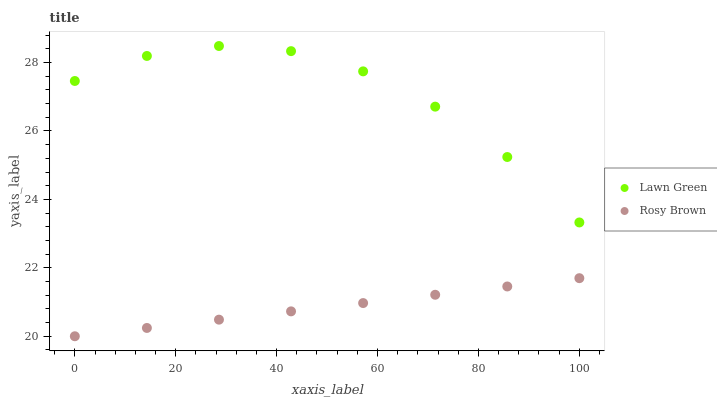Does Rosy Brown have the minimum area under the curve?
Answer yes or no. Yes. Does Lawn Green have the maximum area under the curve?
Answer yes or no. Yes. Does Rosy Brown have the maximum area under the curve?
Answer yes or no. No. Is Rosy Brown the smoothest?
Answer yes or no. Yes. Is Lawn Green the roughest?
Answer yes or no. Yes. Is Rosy Brown the roughest?
Answer yes or no. No. Does Rosy Brown have the lowest value?
Answer yes or no. Yes. Does Lawn Green have the highest value?
Answer yes or no. Yes. Does Rosy Brown have the highest value?
Answer yes or no. No. Is Rosy Brown less than Lawn Green?
Answer yes or no. Yes. Is Lawn Green greater than Rosy Brown?
Answer yes or no. Yes. Does Rosy Brown intersect Lawn Green?
Answer yes or no. No. 